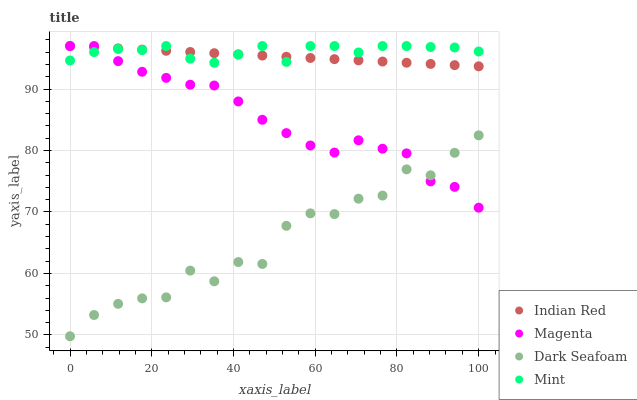Does Dark Seafoam have the minimum area under the curve?
Answer yes or no. Yes. Does Mint have the maximum area under the curve?
Answer yes or no. Yes. Does Mint have the minimum area under the curve?
Answer yes or no. No. Does Dark Seafoam have the maximum area under the curve?
Answer yes or no. No. Is Indian Red the smoothest?
Answer yes or no. Yes. Is Dark Seafoam the roughest?
Answer yes or no. Yes. Is Mint the smoothest?
Answer yes or no. No. Is Mint the roughest?
Answer yes or no. No. Does Dark Seafoam have the lowest value?
Answer yes or no. Yes. Does Mint have the lowest value?
Answer yes or no. No. Does Indian Red have the highest value?
Answer yes or no. Yes. Does Dark Seafoam have the highest value?
Answer yes or no. No. Is Dark Seafoam less than Indian Red?
Answer yes or no. Yes. Is Indian Red greater than Dark Seafoam?
Answer yes or no. Yes. Does Indian Red intersect Magenta?
Answer yes or no. Yes. Is Indian Red less than Magenta?
Answer yes or no. No. Is Indian Red greater than Magenta?
Answer yes or no. No. Does Dark Seafoam intersect Indian Red?
Answer yes or no. No. 